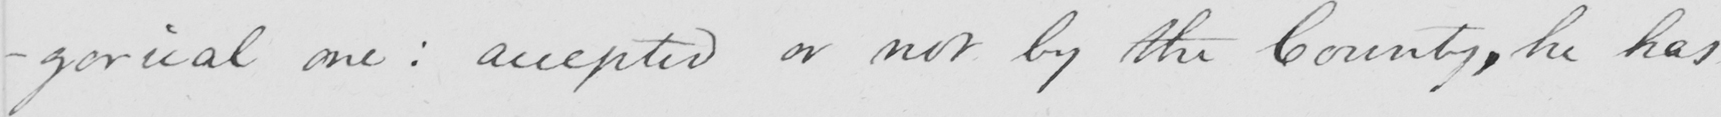Can you read and transcribe this handwriting? -gorical one :  accepted or not by the County , he has 